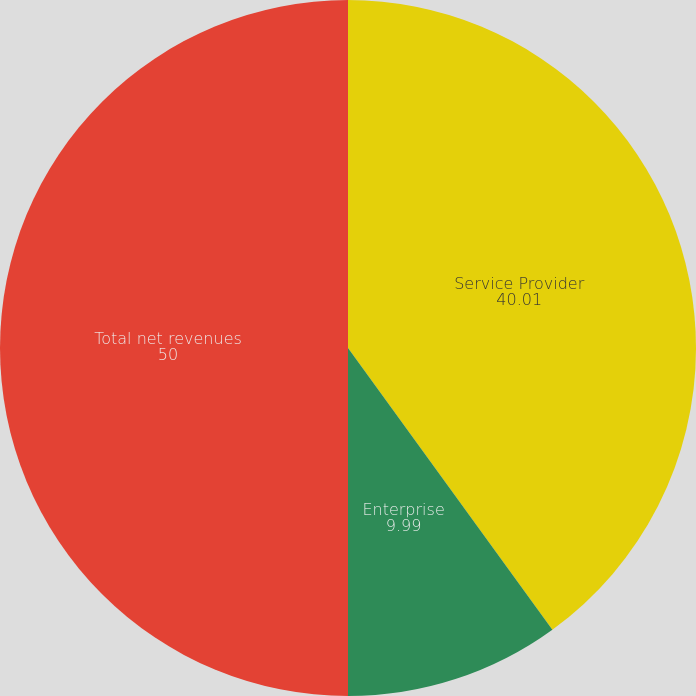<chart> <loc_0><loc_0><loc_500><loc_500><pie_chart><fcel>Service Provider<fcel>Enterprise<fcel>Total net revenues<nl><fcel>40.01%<fcel>9.99%<fcel>50.0%<nl></chart> 